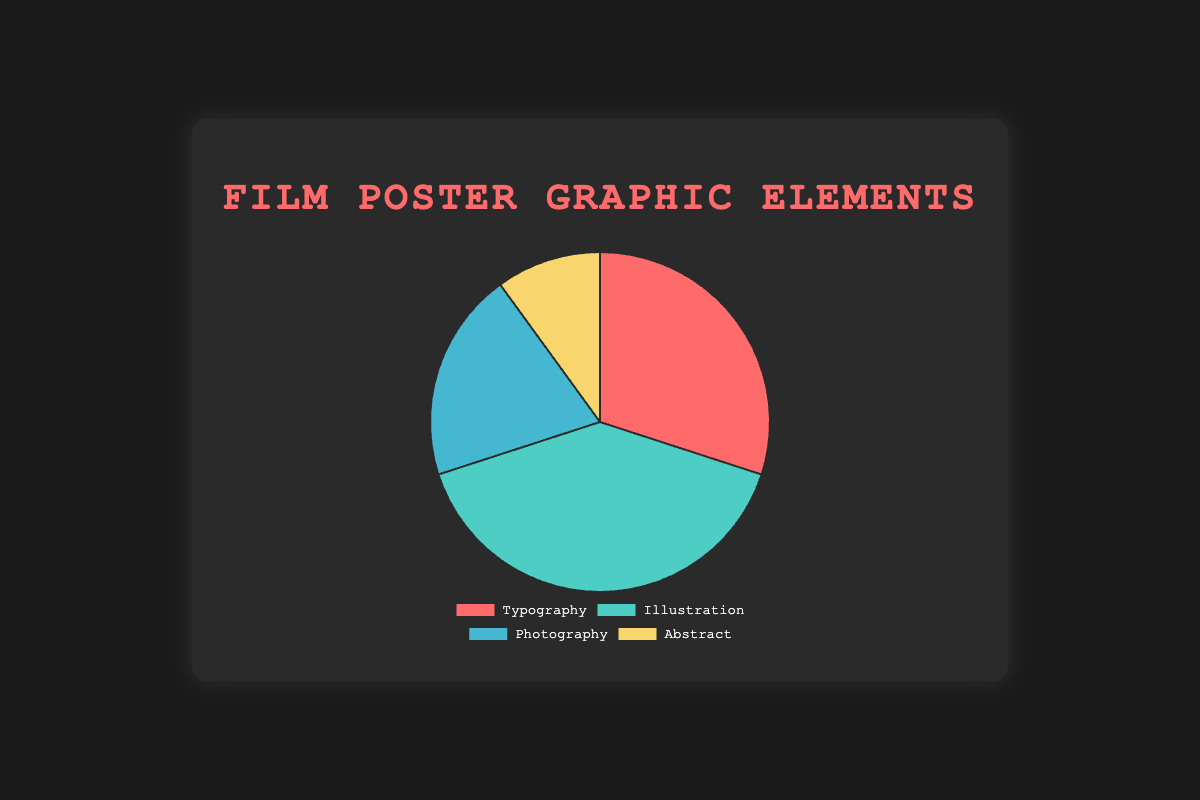Which graphic element has the highest percentage in the film posters? By looking at the pie chart, we can see that "Illustration" has the largest segment with 40%.
Answer: Illustration Which graphic element contributes the least to the overall design of the film posters? The pie chart indicates that "Abstract" has the smallest segment at 10%.
Answer: Abstract What is the difference in the percentage contribution between Typography and Photography? Typography has 30%, and Photography has 20%. The difference is 30% - 20% = 10%.
Answer: 10% If you combine Typography and Abstract, what is their total percentage contribution? Typography contributes 30%, and Abstract contributes 10%. Their combined total is 30% + 10% = 40%.
Answer: 40% How does the combined percentage of Illustration and Abstract compare to Typography? Illustration is 40%, and Abstract is 10%. Their combined total is 40% + 10% = 50%. Typography is 30%. 50% is greater than 30%.
Answer: Greater Which graphic element is represented by the green color in the pie chart? According to the visual attributes, the green segment represents "Illustration" with 40%.
Answer: Illustration Compare the contributions of Typography to the contributions of Abstract. Which is higher and by how much? Typography stands at 30%, while Abstract is at 10%. Typography is higher by 30% - 10% = 20%.
Answer: Typography by 20% Which graphic element is depicted in blue in the chart? The pie chart visually represents "Photography" using the blue color segment at 20%.
Answer: Photography What is the combined percentage of Illustration and Photography? Illustration accounts for 40%, and Photography accounts for 20%. Their combined percentage is 40% + 20% = 60%.
Answer: 60% 